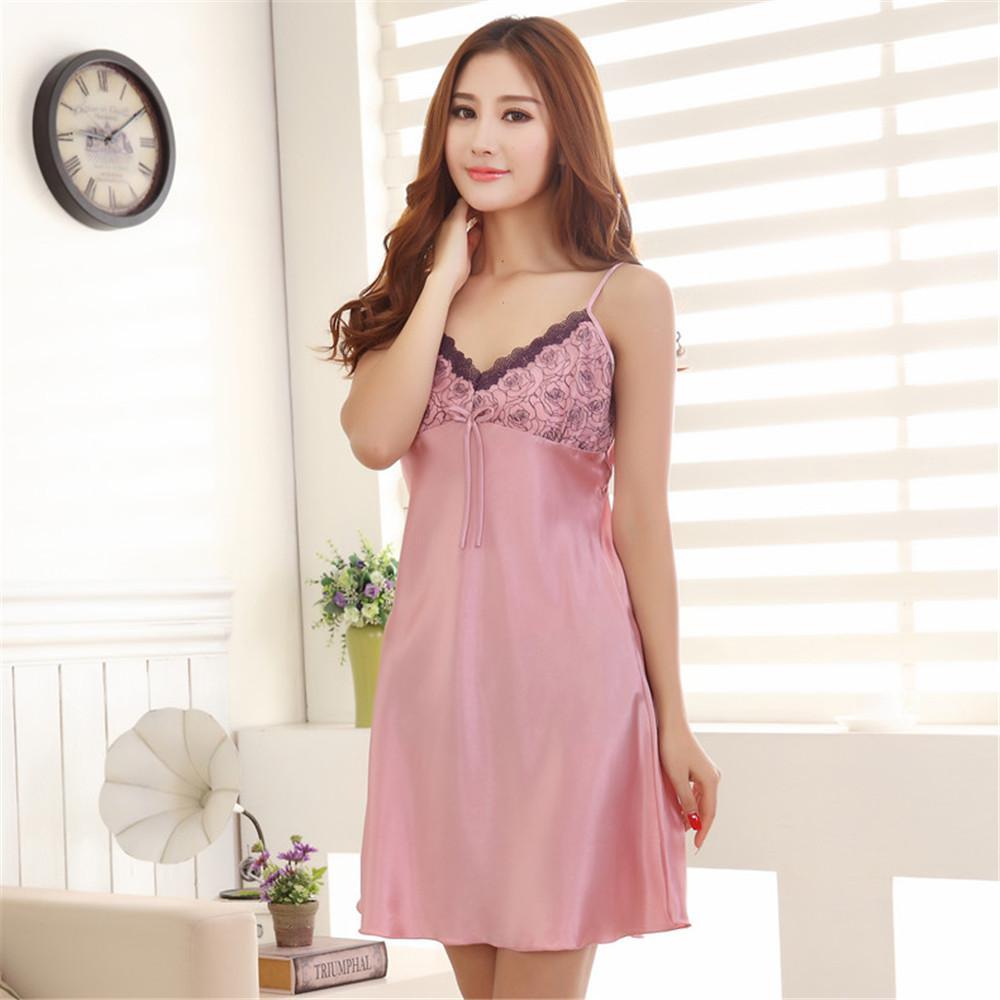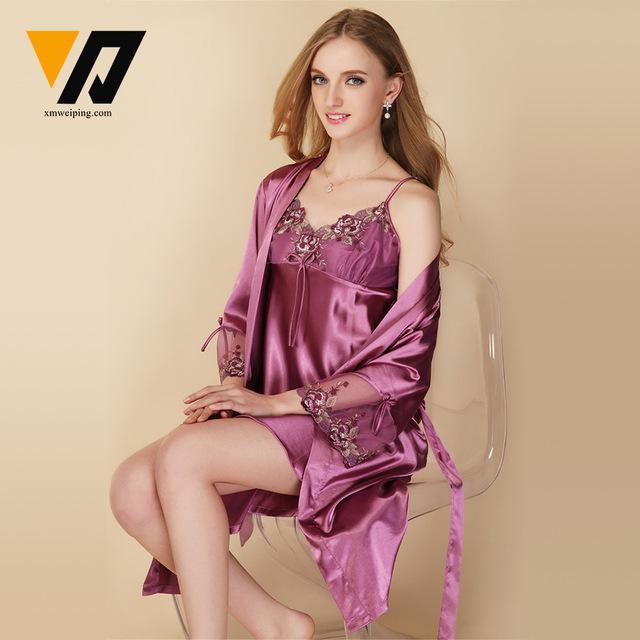The first image is the image on the left, the second image is the image on the right. For the images displayed, is the sentence "In one image, a woman in lingerie is standing; and in the other image, a woman in lingerie is seated and smiling." factually correct? Answer yes or no. Yes. The first image is the image on the left, the second image is the image on the right. Given the left and right images, does the statement "The image to the left features an asian woman." hold true? Answer yes or no. Yes. 